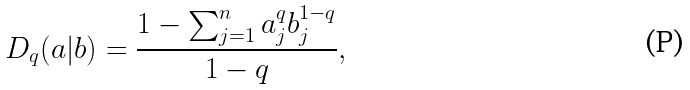<formula> <loc_0><loc_0><loc_500><loc_500>D _ { q } ( a | b ) = \frac { 1 - \sum _ { j = 1 } ^ { n } a _ { j } ^ { q } b _ { j } ^ { 1 - q } } { 1 - q } ,</formula> 